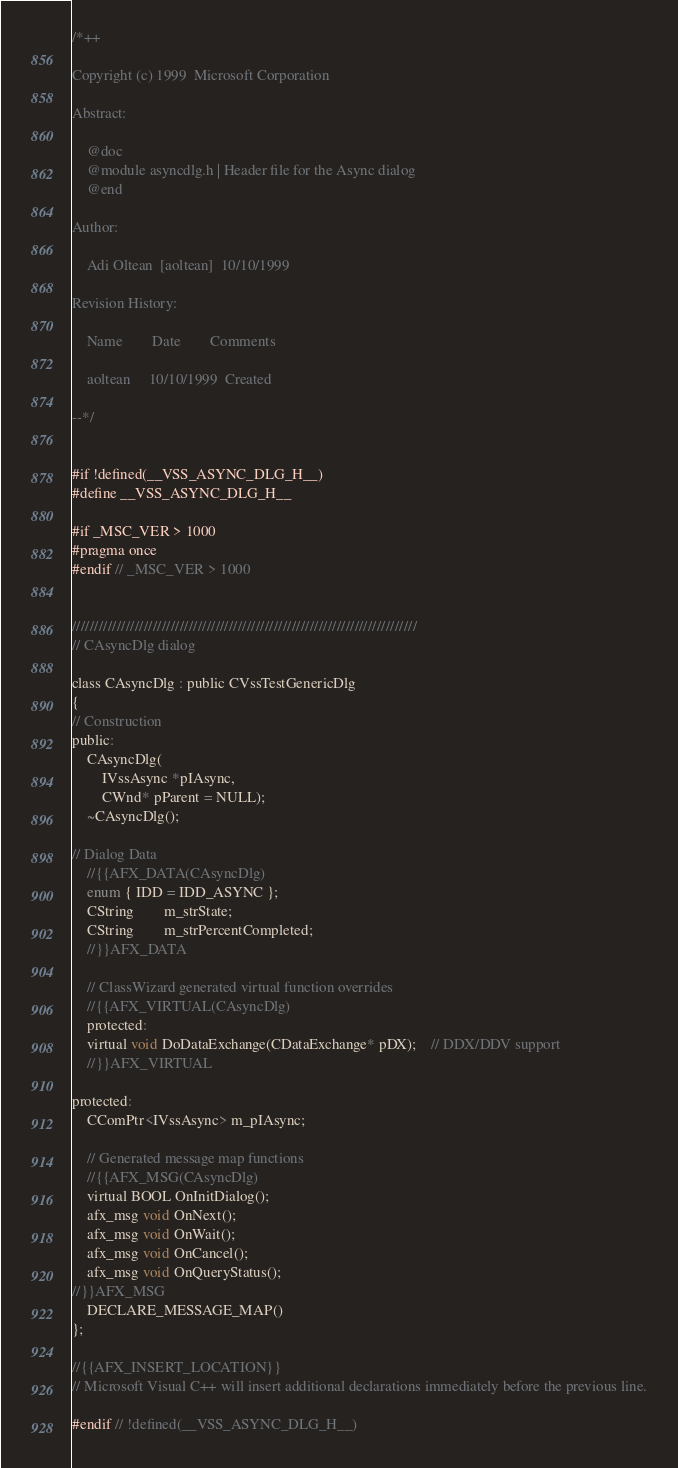<code> <loc_0><loc_0><loc_500><loc_500><_C_>/*++

Copyright (c) 1999  Microsoft Corporation

Abstract:

    @doc
    @module asyncdlg.h | Header file for the Async dialog
    @end

Author:

    Adi Oltean  [aoltean]  10/10/1999

Revision History:

    Name        Date        Comments

    aoltean     10/10/1999  Created

--*/


#if !defined(__VSS_ASYNC_DLG_H__)
#define __VSS_ASYNC_DLG_H__

#if _MSC_VER > 1000
#pragma once
#endif // _MSC_VER > 1000


/////////////////////////////////////////////////////////////////////////////
// CAsyncDlg dialog

class CAsyncDlg : public CVssTestGenericDlg
{
// Construction
public:
    CAsyncDlg(
        IVssAsync *pIAsync,
        CWnd* pParent = NULL); 
    ~CAsyncDlg();

// Dialog Data
    //{{AFX_DATA(CAsyncDlg)
	enum { IDD = IDD_ASYNC };
	CString	    m_strState;
	CString	    m_strPercentCompleted;
	//}}AFX_DATA

    // ClassWizard generated virtual function overrides
    //{{AFX_VIRTUAL(CAsyncDlg)
    protected:
    virtual void DoDataExchange(CDataExchange* pDX);    // DDX/DDV support
    //}}AFX_VIRTUAL

protected:
    CComPtr<IVssAsync> m_pIAsync;

    // Generated message map functions
    //{{AFX_MSG(CAsyncDlg)
    virtual BOOL OnInitDialog();
    afx_msg void OnNext();
    afx_msg void OnWait();
    afx_msg void OnCancel();
    afx_msg void OnQueryStatus();
//}}AFX_MSG
    DECLARE_MESSAGE_MAP()
};

//{{AFX_INSERT_LOCATION}}
// Microsoft Visual C++ will insert additional declarations immediately before the previous line.

#endif // !defined(__VSS_ASYNC_DLG_H__)
</code> 